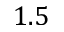Convert formula to latex. <formula><loc_0><loc_0><loc_500><loc_500>1 . 5</formula> 